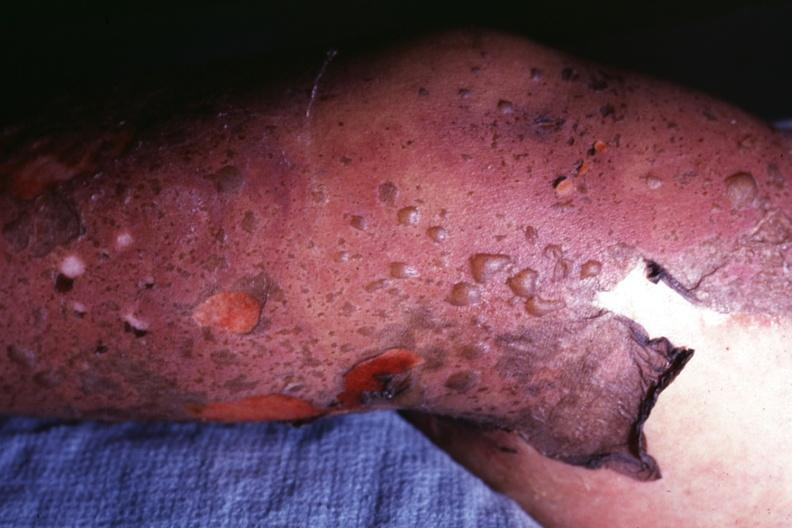s hilar cell tumor correct diagnosis as i do not have protocol?
Answer the question using a single word or phrase. No 